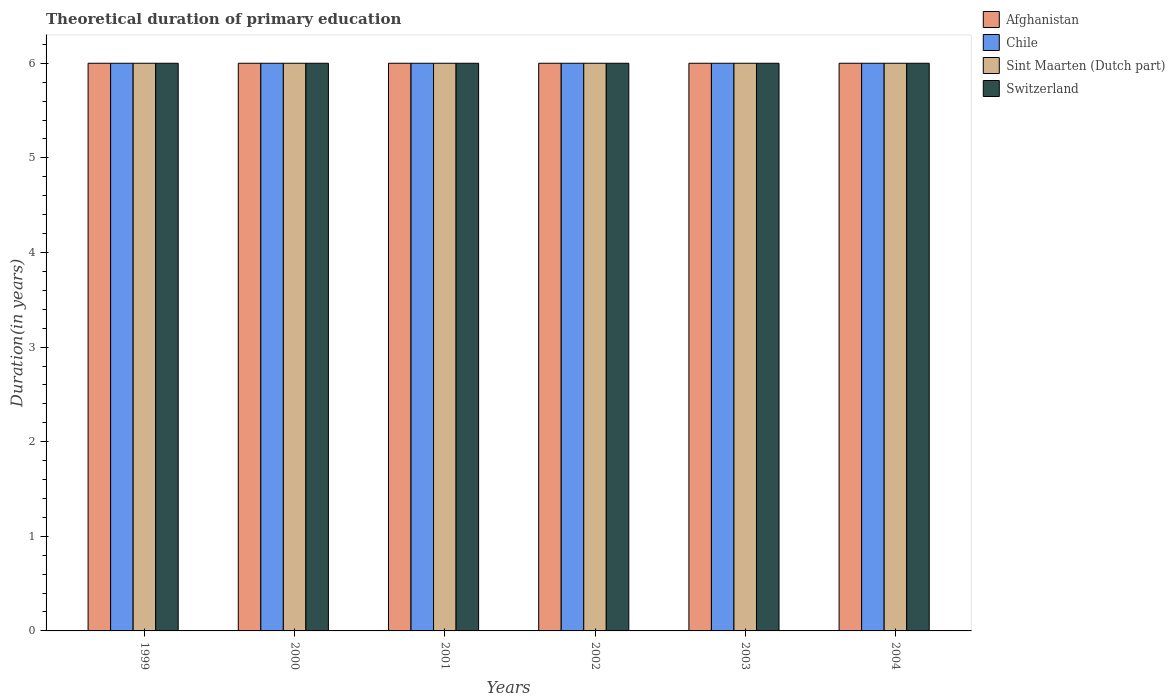How many different coloured bars are there?
Provide a short and direct response. 4. Are the number of bars on each tick of the X-axis equal?
Provide a short and direct response. Yes. How many bars are there on the 3rd tick from the left?
Your response must be concise. 4. In how many cases, is the number of bars for a given year not equal to the number of legend labels?
Give a very brief answer. 0. What is the total theoretical duration of primary education in Chile in 2003?
Ensure brevity in your answer.  6. In which year was the total theoretical duration of primary education in Sint Maarten (Dutch part) maximum?
Make the answer very short. 1999. In which year was the total theoretical duration of primary education in Afghanistan minimum?
Your response must be concise. 1999. What is the total total theoretical duration of primary education in Chile in the graph?
Offer a very short reply. 36. What is the average total theoretical duration of primary education in Chile per year?
Keep it short and to the point. 6. In the year 2004, what is the difference between the total theoretical duration of primary education in Chile and total theoretical duration of primary education in Afghanistan?
Your answer should be very brief. 0. In how many years, is the total theoretical duration of primary education in Sint Maarten (Dutch part) greater than 1 years?
Provide a short and direct response. 6. What is the ratio of the total theoretical duration of primary education in Chile in 2000 to that in 2001?
Your answer should be compact. 1. Is the total theoretical duration of primary education in Sint Maarten (Dutch part) in 1999 less than that in 2003?
Provide a short and direct response. No. What is the difference between the highest and the second highest total theoretical duration of primary education in Afghanistan?
Your answer should be very brief. 0. Is the sum of the total theoretical duration of primary education in Sint Maarten (Dutch part) in 2001 and 2002 greater than the maximum total theoretical duration of primary education in Switzerland across all years?
Offer a terse response. Yes. Is it the case that in every year, the sum of the total theoretical duration of primary education in Chile and total theoretical duration of primary education in Afghanistan is greater than the sum of total theoretical duration of primary education in Switzerland and total theoretical duration of primary education in Sint Maarten (Dutch part)?
Provide a succinct answer. No. What does the 1st bar from the left in 1999 represents?
Your answer should be very brief. Afghanistan. How many bars are there?
Make the answer very short. 24. Are all the bars in the graph horizontal?
Your answer should be compact. No. How many years are there in the graph?
Make the answer very short. 6. Where does the legend appear in the graph?
Provide a short and direct response. Top right. What is the title of the graph?
Your answer should be very brief. Theoretical duration of primary education. What is the label or title of the X-axis?
Provide a short and direct response. Years. What is the label or title of the Y-axis?
Your answer should be compact. Duration(in years). What is the Duration(in years) in Sint Maarten (Dutch part) in 1999?
Provide a short and direct response. 6. What is the Duration(in years) of Chile in 2000?
Your answer should be very brief. 6. What is the Duration(in years) in Switzerland in 2000?
Your response must be concise. 6. What is the Duration(in years) in Chile in 2001?
Your response must be concise. 6. What is the Duration(in years) of Chile in 2002?
Give a very brief answer. 6. What is the Duration(in years) of Sint Maarten (Dutch part) in 2002?
Ensure brevity in your answer.  6. What is the Duration(in years) in Chile in 2003?
Offer a terse response. 6. What is the Duration(in years) in Sint Maarten (Dutch part) in 2003?
Your response must be concise. 6. What is the Duration(in years) of Sint Maarten (Dutch part) in 2004?
Your answer should be compact. 6. What is the Duration(in years) of Switzerland in 2004?
Your response must be concise. 6. Across all years, what is the maximum Duration(in years) in Chile?
Offer a very short reply. 6. Across all years, what is the minimum Duration(in years) of Afghanistan?
Give a very brief answer. 6. Across all years, what is the minimum Duration(in years) of Chile?
Your response must be concise. 6. Across all years, what is the minimum Duration(in years) of Switzerland?
Your response must be concise. 6. What is the total Duration(in years) in Afghanistan in the graph?
Keep it short and to the point. 36. What is the total Duration(in years) of Chile in the graph?
Offer a very short reply. 36. What is the difference between the Duration(in years) in Afghanistan in 1999 and that in 2000?
Ensure brevity in your answer.  0. What is the difference between the Duration(in years) in Switzerland in 1999 and that in 2000?
Keep it short and to the point. 0. What is the difference between the Duration(in years) in Chile in 1999 and that in 2001?
Ensure brevity in your answer.  0. What is the difference between the Duration(in years) in Sint Maarten (Dutch part) in 1999 and that in 2001?
Keep it short and to the point. 0. What is the difference between the Duration(in years) in Switzerland in 1999 and that in 2001?
Your response must be concise. 0. What is the difference between the Duration(in years) in Afghanistan in 1999 and that in 2002?
Your answer should be compact. 0. What is the difference between the Duration(in years) in Switzerland in 1999 and that in 2002?
Keep it short and to the point. 0. What is the difference between the Duration(in years) of Switzerland in 1999 and that in 2003?
Your answer should be compact. 0. What is the difference between the Duration(in years) of Afghanistan in 1999 and that in 2004?
Provide a succinct answer. 0. What is the difference between the Duration(in years) of Sint Maarten (Dutch part) in 1999 and that in 2004?
Ensure brevity in your answer.  0. What is the difference between the Duration(in years) of Afghanistan in 2000 and that in 2001?
Your response must be concise. 0. What is the difference between the Duration(in years) in Chile in 2000 and that in 2001?
Provide a short and direct response. 0. What is the difference between the Duration(in years) of Sint Maarten (Dutch part) in 2000 and that in 2001?
Your answer should be very brief. 0. What is the difference between the Duration(in years) of Afghanistan in 2000 and that in 2002?
Offer a terse response. 0. What is the difference between the Duration(in years) of Chile in 2000 and that in 2003?
Give a very brief answer. 0. What is the difference between the Duration(in years) in Switzerland in 2000 and that in 2003?
Give a very brief answer. 0. What is the difference between the Duration(in years) of Afghanistan in 2000 and that in 2004?
Offer a terse response. 0. What is the difference between the Duration(in years) of Switzerland in 2000 and that in 2004?
Give a very brief answer. 0. What is the difference between the Duration(in years) of Switzerland in 2001 and that in 2002?
Provide a succinct answer. 0. What is the difference between the Duration(in years) in Afghanistan in 2001 and that in 2003?
Ensure brevity in your answer.  0. What is the difference between the Duration(in years) in Chile in 2001 and that in 2003?
Keep it short and to the point. 0. What is the difference between the Duration(in years) in Sint Maarten (Dutch part) in 2001 and that in 2003?
Provide a short and direct response. 0. What is the difference between the Duration(in years) in Switzerland in 2001 and that in 2003?
Ensure brevity in your answer.  0. What is the difference between the Duration(in years) of Afghanistan in 2001 and that in 2004?
Make the answer very short. 0. What is the difference between the Duration(in years) of Sint Maarten (Dutch part) in 2001 and that in 2004?
Offer a terse response. 0. What is the difference between the Duration(in years) of Afghanistan in 2002 and that in 2003?
Provide a succinct answer. 0. What is the difference between the Duration(in years) of Chile in 2002 and that in 2003?
Your answer should be compact. 0. What is the difference between the Duration(in years) of Switzerland in 2002 and that in 2003?
Offer a terse response. 0. What is the difference between the Duration(in years) in Sint Maarten (Dutch part) in 2002 and that in 2004?
Your answer should be compact. 0. What is the difference between the Duration(in years) of Sint Maarten (Dutch part) in 2003 and that in 2004?
Provide a short and direct response. 0. What is the difference between the Duration(in years) in Afghanistan in 1999 and the Duration(in years) in Chile in 2000?
Make the answer very short. 0. What is the difference between the Duration(in years) in Afghanistan in 1999 and the Duration(in years) in Switzerland in 2000?
Your answer should be very brief. 0. What is the difference between the Duration(in years) in Chile in 1999 and the Duration(in years) in Sint Maarten (Dutch part) in 2000?
Give a very brief answer. 0. What is the difference between the Duration(in years) in Afghanistan in 1999 and the Duration(in years) in Chile in 2001?
Provide a succinct answer. 0. What is the difference between the Duration(in years) of Afghanistan in 1999 and the Duration(in years) of Sint Maarten (Dutch part) in 2001?
Offer a terse response. 0. What is the difference between the Duration(in years) of Afghanistan in 1999 and the Duration(in years) of Switzerland in 2001?
Give a very brief answer. 0. What is the difference between the Duration(in years) in Chile in 1999 and the Duration(in years) in Sint Maarten (Dutch part) in 2001?
Your response must be concise. 0. What is the difference between the Duration(in years) in Sint Maarten (Dutch part) in 1999 and the Duration(in years) in Switzerland in 2001?
Offer a terse response. 0. What is the difference between the Duration(in years) of Afghanistan in 1999 and the Duration(in years) of Chile in 2002?
Make the answer very short. 0. What is the difference between the Duration(in years) in Afghanistan in 1999 and the Duration(in years) in Switzerland in 2002?
Your answer should be very brief. 0. What is the difference between the Duration(in years) of Sint Maarten (Dutch part) in 1999 and the Duration(in years) of Switzerland in 2002?
Provide a short and direct response. 0. What is the difference between the Duration(in years) of Afghanistan in 1999 and the Duration(in years) of Switzerland in 2003?
Provide a succinct answer. 0. What is the difference between the Duration(in years) of Chile in 1999 and the Duration(in years) of Switzerland in 2003?
Your answer should be very brief. 0. What is the difference between the Duration(in years) in Afghanistan in 1999 and the Duration(in years) in Chile in 2004?
Provide a short and direct response. 0. What is the difference between the Duration(in years) in Chile in 1999 and the Duration(in years) in Switzerland in 2004?
Give a very brief answer. 0. What is the difference between the Duration(in years) in Sint Maarten (Dutch part) in 1999 and the Duration(in years) in Switzerland in 2004?
Provide a short and direct response. 0. What is the difference between the Duration(in years) in Afghanistan in 2000 and the Duration(in years) in Sint Maarten (Dutch part) in 2001?
Provide a short and direct response. 0. What is the difference between the Duration(in years) of Afghanistan in 2000 and the Duration(in years) of Switzerland in 2001?
Provide a short and direct response. 0. What is the difference between the Duration(in years) of Chile in 2000 and the Duration(in years) of Sint Maarten (Dutch part) in 2001?
Offer a very short reply. 0. What is the difference between the Duration(in years) of Chile in 2000 and the Duration(in years) of Switzerland in 2001?
Your response must be concise. 0. What is the difference between the Duration(in years) in Afghanistan in 2000 and the Duration(in years) in Sint Maarten (Dutch part) in 2002?
Your response must be concise. 0. What is the difference between the Duration(in years) of Chile in 2000 and the Duration(in years) of Switzerland in 2002?
Make the answer very short. 0. What is the difference between the Duration(in years) in Afghanistan in 2000 and the Duration(in years) in Sint Maarten (Dutch part) in 2003?
Your answer should be very brief. 0. What is the difference between the Duration(in years) of Afghanistan in 2000 and the Duration(in years) of Switzerland in 2003?
Keep it short and to the point. 0. What is the difference between the Duration(in years) of Afghanistan in 2000 and the Duration(in years) of Chile in 2004?
Provide a succinct answer. 0. What is the difference between the Duration(in years) in Afghanistan in 2000 and the Duration(in years) in Switzerland in 2004?
Give a very brief answer. 0. What is the difference between the Duration(in years) in Chile in 2000 and the Duration(in years) in Sint Maarten (Dutch part) in 2004?
Give a very brief answer. 0. What is the difference between the Duration(in years) of Afghanistan in 2001 and the Duration(in years) of Chile in 2002?
Provide a succinct answer. 0. What is the difference between the Duration(in years) of Afghanistan in 2001 and the Duration(in years) of Sint Maarten (Dutch part) in 2002?
Ensure brevity in your answer.  0. What is the difference between the Duration(in years) of Chile in 2001 and the Duration(in years) of Sint Maarten (Dutch part) in 2002?
Your answer should be compact. 0. What is the difference between the Duration(in years) of Chile in 2001 and the Duration(in years) of Switzerland in 2003?
Offer a terse response. 0. What is the difference between the Duration(in years) of Sint Maarten (Dutch part) in 2001 and the Duration(in years) of Switzerland in 2003?
Your response must be concise. 0. What is the difference between the Duration(in years) of Afghanistan in 2001 and the Duration(in years) of Switzerland in 2004?
Offer a very short reply. 0. What is the difference between the Duration(in years) in Sint Maarten (Dutch part) in 2001 and the Duration(in years) in Switzerland in 2004?
Keep it short and to the point. 0. What is the difference between the Duration(in years) of Chile in 2002 and the Duration(in years) of Sint Maarten (Dutch part) in 2003?
Ensure brevity in your answer.  0. What is the difference between the Duration(in years) of Sint Maarten (Dutch part) in 2002 and the Duration(in years) of Switzerland in 2003?
Keep it short and to the point. 0. What is the difference between the Duration(in years) in Afghanistan in 2002 and the Duration(in years) in Chile in 2004?
Your response must be concise. 0. What is the difference between the Duration(in years) of Afghanistan in 2002 and the Duration(in years) of Switzerland in 2004?
Make the answer very short. 0. What is the difference between the Duration(in years) of Chile in 2002 and the Duration(in years) of Sint Maarten (Dutch part) in 2004?
Provide a succinct answer. 0. What is the difference between the Duration(in years) of Sint Maarten (Dutch part) in 2002 and the Duration(in years) of Switzerland in 2004?
Make the answer very short. 0. What is the difference between the Duration(in years) in Afghanistan in 2003 and the Duration(in years) in Chile in 2004?
Your answer should be very brief. 0. What is the difference between the Duration(in years) in Afghanistan in 2003 and the Duration(in years) in Sint Maarten (Dutch part) in 2004?
Offer a very short reply. 0. What is the difference between the Duration(in years) of Chile in 2003 and the Duration(in years) of Sint Maarten (Dutch part) in 2004?
Give a very brief answer. 0. What is the difference between the Duration(in years) in Sint Maarten (Dutch part) in 2003 and the Duration(in years) in Switzerland in 2004?
Keep it short and to the point. 0. What is the average Duration(in years) of Switzerland per year?
Give a very brief answer. 6. In the year 1999, what is the difference between the Duration(in years) in Sint Maarten (Dutch part) and Duration(in years) in Switzerland?
Ensure brevity in your answer.  0. In the year 2000, what is the difference between the Duration(in years) in Afghanistan and Duration(in years) in Chile?
Make the answer very short. 0. In the year 2000, what is the difference between the Duration(in years) in Afghanistan and Duration(in years) in Sint Maarten (Dutch part)?
Your answer should be very brief. 0. In the year 2000, what is the difference between the Duration(in years) in Afghanistan and Duration(in years) in Switzerland?
Your response must be concise. 0. In the year 2000, what is the difference between the Duration(in years) in Chile and Duration(in years) in Switzerland?
Make the answer very short. 0. In the year 2001, what is the difference between the Duration(in years) in Afghanistan and Duration(in years) in Chile?
Keep it short and to the point. 0. In the year 2001, what is the difference between the Duration(in years) in Afghanistan and Duration(in years) in Sint Maarten (Dutch part)?
Keep it short and to the point. 0. In the year 2001, what is the difference between the Duration(in years) in Chile and Duration(in years) in Switzerland?
Keep it short and to the point. 0. In the year 2001, what is the difference between the Duration(in years) of Sint Maarten (Dutch part) and Duration(in years) of Switzerland?
Give a very brief answer. 0. In the year 2002, what is the difference between the Duration(in years) in Afghanistan and Duration(in years) in Sint Maarten (Dutch part)?
Offer a very short reply. 0. In the year 2002, what is the difference between the Duration(in years) in Chile and Duration(in years) in Sint Maarten (Dutch part)?
Your answer should be very brief. 0. In the year 2003, what is the difference between the Duration(in years) of Afghanistan and Duration(in years) of Chile?
Give a very brief answer. 0. In the year 2003, what is the difference between the Duration(in years) of Afghanistan and Duration(in years) of Sint Maarten (Dutch part)?
Keep it short and to the point. 0. In the year 2003, what is the difference between the Duration(in years) in Afghanistan and Duration(in years) in Switzerland?
Your answer should be very brief. 0. In the year 2003, what is the difference between the Duration(in years) in Chile and Duration(in years) in Sint Maarten (Dutch part)?
Ensure brevity in your answer.  0. In the year 2003, what is the difference between the Duration(in years) of Chile and Duration(in years) of Switzerland?
Offer a very short reply. 0. In the year 2004, what is the difference between the Duration(in years) in Afghanistan and Duration(in years) in Chile?
Give a very brief answer. 0. In the year 2004, what is the difference between the Duration(in years) in Afghanistan and Duration(in years) in Sint Maarten (Dutch part)?
Your response must be concise. 0. In the year 2004, what is the difference between the Duration(in years) of Chile and Duration(in years) of Sint Maarten (Dutch part)?
Provide a succinct answer. 0. What is the ratio of the Duration(in years) of Afghanistan in 1999 to that in 2000?
Keep it short and to the point. 1. What is the ratio of the Duration(in years) of Sint Maarten (Dutch part) in 1999 to that in 2000?
Your answer should be very brief. 1. What is the ratio of the Duration(in years) of Switzerland in 1999 to that in 2000?
Your answer should be very brief. 1. What is the ratio of the Duration(in years) in Afghanistan in 1999 to that in 2001?
Make the answer very short. 1. What is the ratio of the Duration(in years) in Chile in 1999 to that in 2001?
Your response must be concise. 1. What is the ratio of the Duration(in years) in Sint Maarten (Dutch part) in 1999 to that in 2001?
Your answer should be very brief. 1. What is the ratio of the Duration(in years) in Sint Maarten (Dutch part) in 1999 to that in 2002?
Your answer should be very brief. 1. What is the ratio of the Duration(in years) in Chile in 1999 to that in 2003?
Ensure brevity in your answer.  1. What is the ratio of the Duration(in years) of Switzerland in 1999 to that in 2003?
Offer a terse response. 1. What is the ratio of the Duration(in years) of Afghanistan in 1999 to that in 2004?
Your response must be concise. 1. What is the ratio of the Duration(in years) of Chile in 1999 to that in 2004?
Your answer should be very brief. 1. What is the ratio of the Duration(in years) in Sint Maarten (Dutch part) in 1999 to that in 2004?
Make the answer very short. 1. What is the ratio of the Duration(in years) of Afghanistan in 2000 to that in 2002?
Your response must be concise. 1. What is the ratio of the Duration(in years) of Chile in 2000 to that in 2002?
Your answer should be very brief. 1. What is the ratio of the Duration(in years) in Sint Maarten (Dutch part) in 2000 to that in 2002?
Keep it short and to the point. 1. What is the ratio of the Duration(in years) of Switzerland in 2000 to that in 2002?
Make the answer very short. 1. What is the ratio of the Duration(in years) in Chile in 2000 to that in 2003?
Give a very brief answer. 1. What is the ratio of the Duration(in years) in Sint Maarten (Dutch part) in 2000 to that in 2003?
Your answer should be very brief. 1. What is the ratio of the Duration(in years) in Switzerland in 2000 to that in 2003?
Ensure brevity in your answer.  1. What is the ratio of the Duration(in years) in Sint Maarten (Dutch part) in 2000 to that in 2004?
Provide a succinct answer. 1. What is the ratio of the Duration(in years) of Switzerland in 2000 to that in 2004?
Offer a very short reply. 1. What is the ratio of the Duration(in years) in Afghanistan in 2001 to that in 2002?
Offer a terse response. 1. What is the ratio of the Duration(in years) in Chile in 2001 to that in 2002?
Ensure brevity in your answer.  1. What is the ratio of the Duration(in years) of Afghanistan in 2001 to that in 2003?
Your response must be concise. 1. What is the ratio of the Duration(in years) of Sint Maarten (Dutch part) in 2001 to that in 2003?
Your answer should be very brief. 1. What is the ratio of the Duration(in years) in Afghanistan in 2001 to that in 2004?
Ensure brevity in your answer.  1. What is the ratio of the Duration(in years) in Chile in 2001 to that in 2004?
Your answer should be very brief. 1. What is the ratio of the Duration(in years) in Switzerland in 2001 to that in 2004?
Offer a very short reply. 1. What is the ratio of the Duration(in years) of Afghanistan in 2002 to that in 2003?
Your response must be concise. 1. What is the ratio of the Duration(in years) in Chile in 2002 to that in 2003?
Make the answer very short. 1. What is the ratio of the Duration(in years) in Chile in 2002 to that in 2004?
Offer a very short reply. 1. What is the ratio of the Duration(in years) of Switzerland in 2002 to that in 2004?
Ensure brevity in your answer.  1. What is the ratio of the Duration(in years) of Switzerland in 2003 to that in 2004?
Your answer should be compact. 1. What is the difference between the highest and the second highest Duration(in years) in Afghanistan?
Offer a very short reply. 0. What is the difference between the highest and the second highest Duration(in years) of Chile?
Offer a terse response. 0. What is the difference between the highest and the lowest Duration(in years) in Afghanistan?
Offer a terse response. 0. What is the difference between the highest and the lowest Duration(in years) of Chile?
Your response must be concise. 0. What is the difference between the highest and the lowest Duration(in years) of Switzerland?
Keep it short and to the point. 0. 